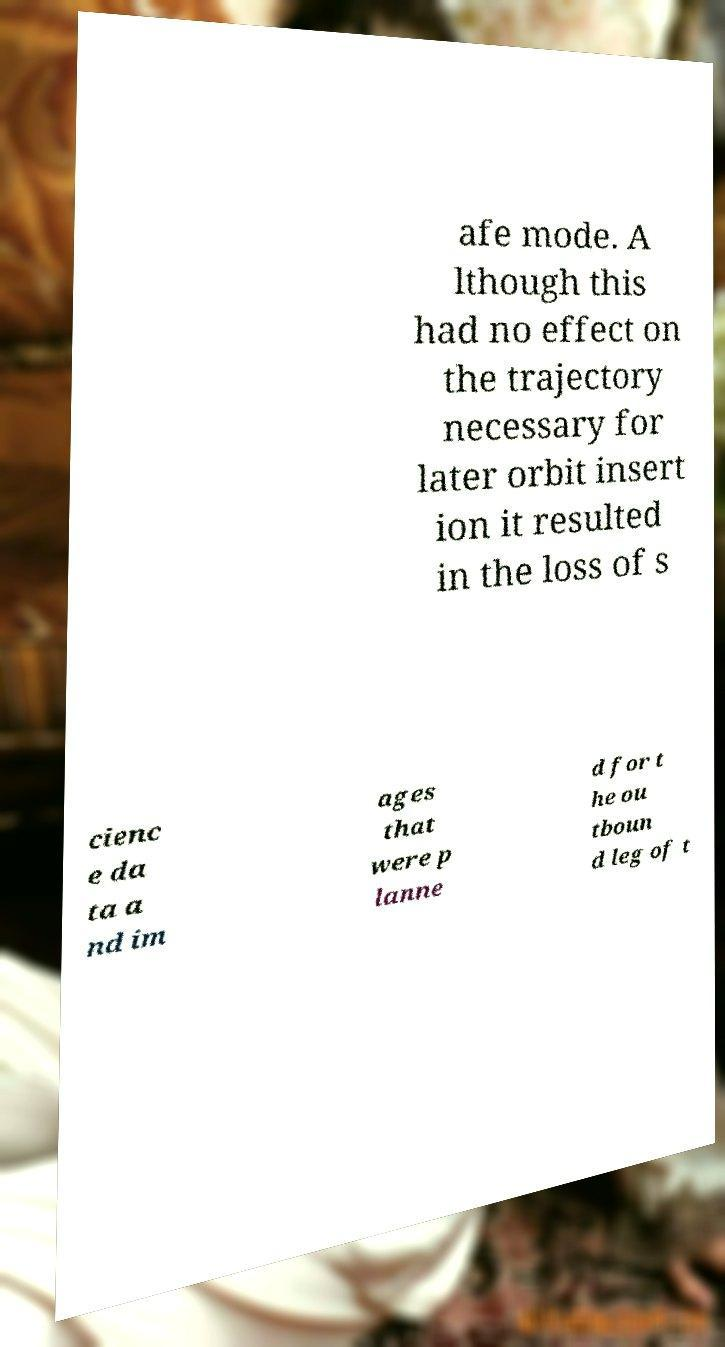For documentation purposes, I need the text within this image transcribed. Could you provide that? afe mode. A lthough this had no effect on the trajectory necessary for later orbit insert ion it resulted in the loss of s cienc e da ta a nd im ages that were p lanne d for t he ou tboun d leg of t 